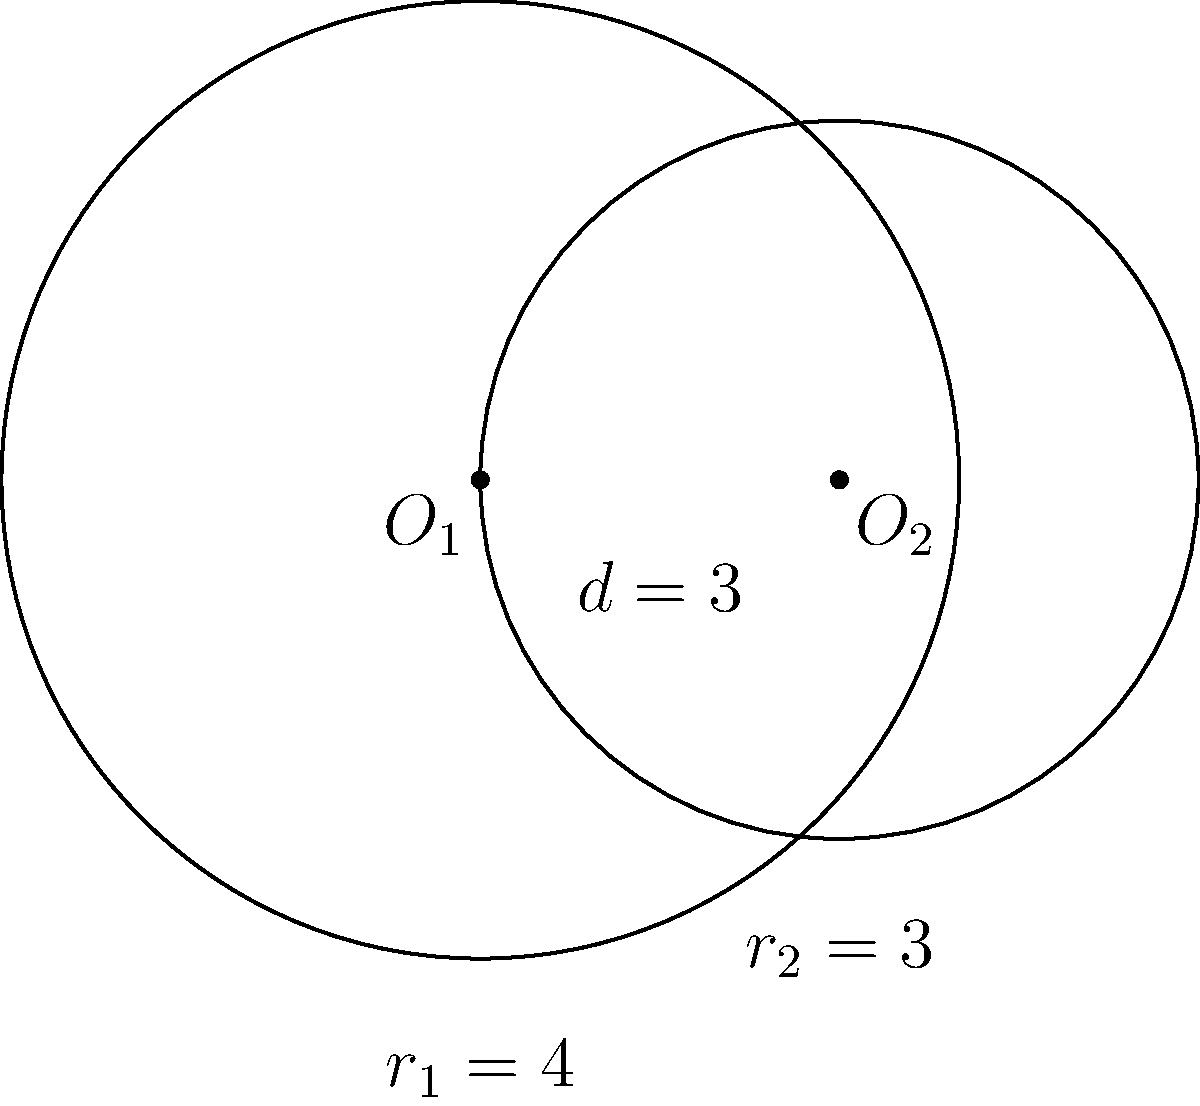In a school garden project, two circular flower beds intersect as shown in the diagram. The center of the larger circle is at $O_1$ with radius $r_1 = 4$ units, and the center of the smaller circle is at $O_2$ with radius $r_2 = 3$ units. The distance between the centers is $d = 3$ units. Calculate the area of the overlapping region where the two flower beds intersect, emphasizing the importance of precise measurements in collaborative projects. To find the area of the overlapping region, we'll use the formula for the area of intersection of two circles. Let's break it down step-by-step:

1) First, we need to calculate the angle $\theta$ (in radians) for each circle sector:

   For circle 1: $\cos(\frac{\theta_1}{2}) = \frac{d^2 + r_1^2 - r_2^2}{2dr_1}$
   $\cos(\frac{\theta_1}{2}) = \frac{3^2 + 4^2 - 3^2}{2 \cdot 3 \cdot 4} = \frac{25}{24}$
   $\theta_1 = 2 \arccos(\frac{25}{24}) \approx 0.7227$ radians

   For circle 2: $\cos(\frac{\theta_2}{2}) = \frac{d^2 + r_2^2 - r_1^2}{2dr_2}$
   $\cos(\frac{\theta_2}{2}) = \frac{3^2 + 3^2 - 4^2}{2 \cdot 3 \cdot 3} = -\frac{1}{6}$
   $\theta_2 = 2 \arccos(-\frac{1}{6}) \approx 2.4189$ radians

2) Now, we can calculate the area of each circular sector:
   
   Area of sector 1 = $\frac{1}{2}r_1^2\theta_1 = \frac{1}{2} \cdot 4^2 \cdot 0.7227 \approx 5.7816$ square units
   Area of sector 2 = $\frac{1}{2}r_2^2\theta_2 = \frac{1}{2} \cdot 3^2 \cdot 2.4189 \approx 10.8851$ square units

3) Next, we calculate the area of the triangle formed by the centers of the circles and one of the intersection points:

   Area of triangle = $\frac{1}{2}d\sqrt{r_1^2 - (\frac{d}{2})^2} + \frac{1}{2}d\sqrt{r_2^2 - (\frac{d}{2})^2}$
                    = $\frac{3}{2}\sqrt{4^2 - (\frac{3}{2})^2} + \frac{3}{2}\sqrt{3^2 - (\frac{3}{2})^2}$
                    = $\frac{3}{2}\sqrt{\frac{55}{4}} + \frac{3}{2}\sqrt{\frac{27}{4}}$
                    $\approx 7.1545$ square units

4) Finally, the area of intersection is the sum of the two sectors minus twice the area of the triangle:

   Area of intersection = $(5.7816 + 10.8851) - 2(7.1545) \approx 2.3577$ square units

This precise calculation demonstrates the importance of accurate measurements in collaborative projects, ensuring that resources are used efficiently and the garden design is implemented correctly.
Answer: $2.3577$ square units 